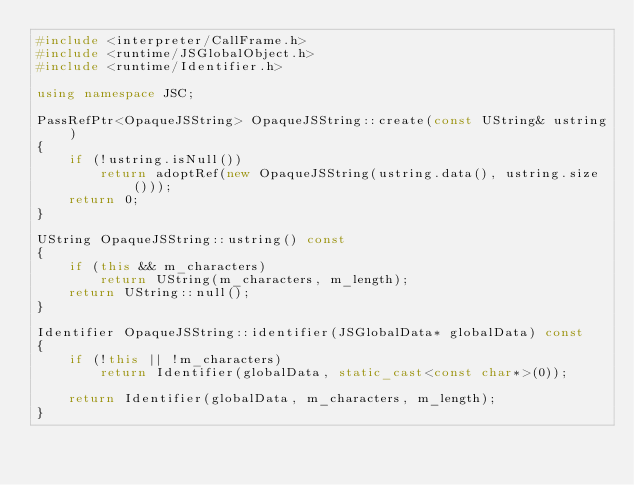<code> <loc_0><loc_0><loc_500><loc_500><_C++_>#include <interpreter/CallFrame.h>
#include <runtime/JSGlobalObject.h>
#include <runtime/Identifier.h>

using namespace JSC;

PassRefPtr<OpaqueJSString> OpaqueJSString::create(const UString& ustring)
{
    if (!ustring.isNull())
        return adoptRef(new OpaqueJSString(ustring.data(), ustring.size()));
    return 0;
}

UString OpaqueJSString::ustring() const
{
    if (this && m_characters)
        return UString(m_characters, m_length);
    return UString::null();
}

Identifier OpaqueJSString::identifier(JSGlobalData* globalData) const
{
    if (!this || !m_characters)
        return Identifier(globalData, static_cast<const char*>(0));

    return Identifier(globalData, m_characters, m_length);
}
</code> 